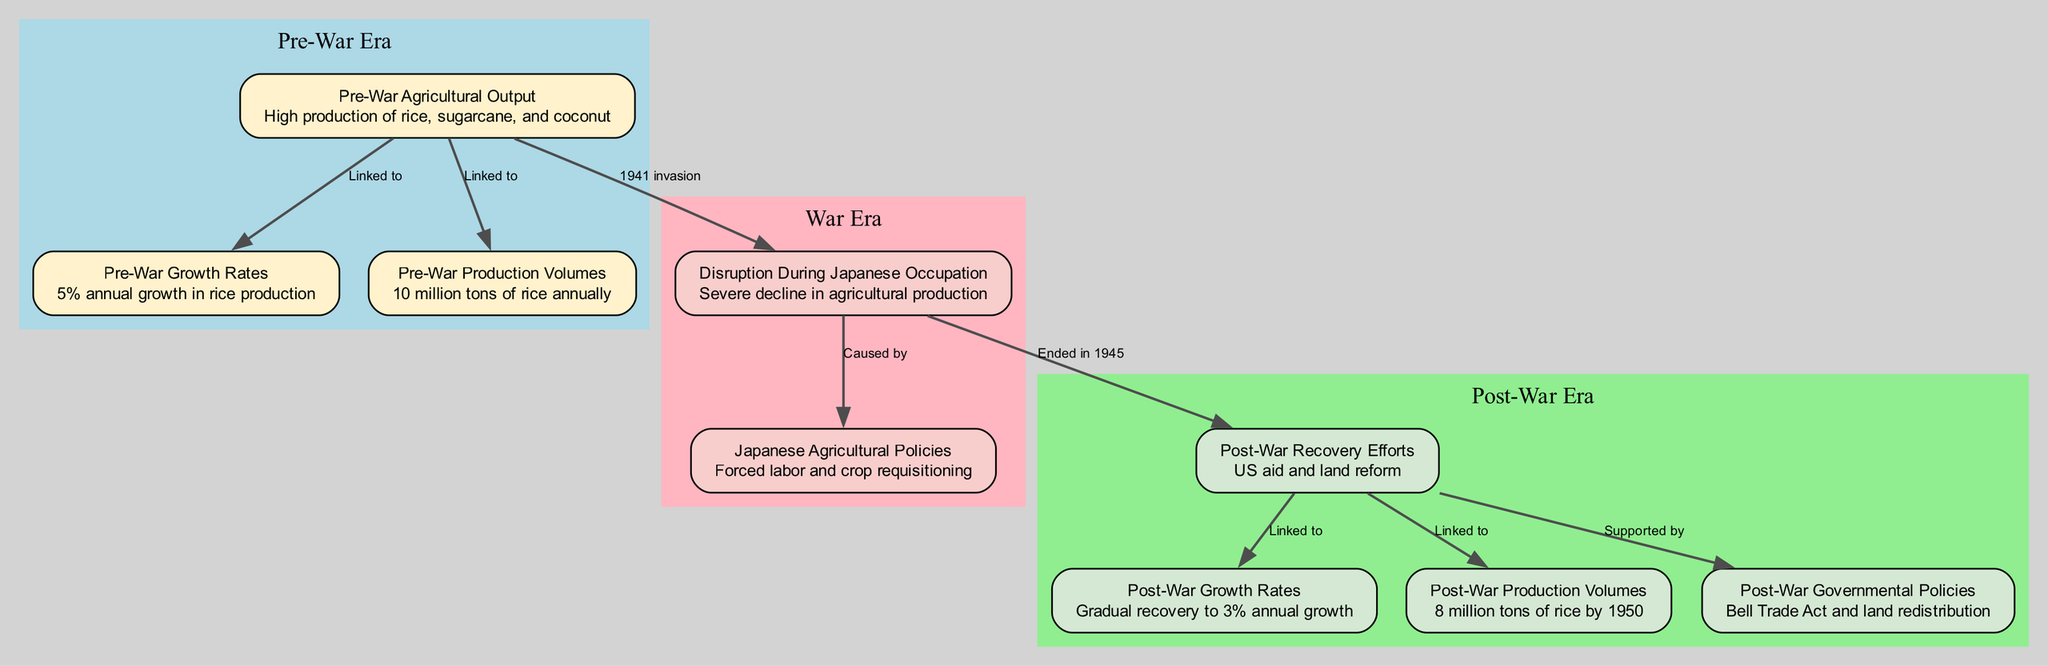What was the agricultural output before the war? The diagram indicates that the pre-war agricultural output included high production of rice, sugarcane, and coconut.
Answer: High production of rice, sugarcane, and coconut What caused the disruption in agricultural production during WWII? The diagram shows that the disruption was caused by the invasion in 1941, leading to severe decline in agricultural production.
Answer: 1941 invasion What was the annual growth rate of rice production before the war? The information in the diagram states that there was a 5% annual growth in rice production before the war.
Answer: 5% annual growth How much rice was produced annually before the war? According to the diagram, the pre-war production volumes indicated that there were 10 million tons of rice annually.
Answer: 10 million tons What policies were implemented during the Japanese occupation? The diagram indicates that Japanese agricultural policies involved forced labor and crop requisitioning.
Answer: Forced labor and crop requisitioning What aided the post-war recovery efforts? The diagram highlights that post-war recovery efforts were supported by US aid and land reform.
Answer: US aid and land reform What was the annual growth rate of rice production post-war? The diagram indicates that the post-war growth rate gradually recovered to a 3% annual growth.
Answer: 3% annual growth How much rice was produced by 1950 after the war? According to the diagram, the post-war production volumes reflected 8 million tons of rice by the year 1950.
Answer: 8 million tons What governmental policy was implemented after the war? The diagram lists the Bell Trade Act and land redistribution as post-war governmental policies.
Answer: Bell Trade Act and land redistribution What relationships are highlighted between the nodes in the post-war segment? The diagram shows that the post-war recovery is linked to growth rates, production volumes, and supported by governmental policies.
Answer: Linked to growth rates, production volumes, and supported by governmental policies 